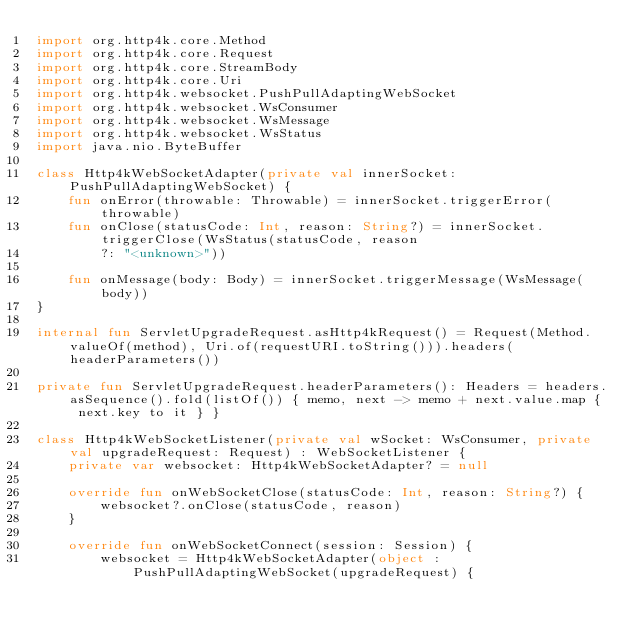Convert code to text. <code><loc_0><loc_0><loc_500><loc_500><_Kotlin_>import org.http4k.core.Method
import org.http4k.core.Request
import org.http4k.core.StreamBody
import org.http4k.core.Uri
import org.http4k.websocket.PushPullAdaptingWebSocket
import org.http4k.websocket.WsConsumer
import org.http4k.websocket.WsMessage
import org.http4k.websocket.WsStatus
import java.nio.ByteBuffer

class Http4kWebSocketAdapter(private val innerSocket: PushPullAdaptingWebSocket) {
    fun onError(throwable: Throwable) = innerSocket.triggerError(throwable)
    fun onClose(statusCode: Int, reason: String?) = innerSocket.triggerClose(WsStatus(statusCode, reason
        ?: "<unknown>"))

    fun onMessage(body: Body) = innerSocket.triggerMessage(WsMessage(body))
}

internal fun ServletUpgradeRequest.asHttp4kRequest() = Request(Method.valueOf(method), Uri.of(requestURI.toString())).headers(headerParameters())

private fun ServletUpgradeRequest.headerParameters(): Headers = headers.asSequence().fold(listOf()) { memo, next -> memo + next.value.map { next.key to it } }

class Http4kWebSocketListener(private val wSocket: WsConsumer, private val upgradeRequest: Request) : WebSocketListener {
    private var websocket: Http4kWebSocketAdapter? = null

    override fun onWebSocketClose(statusCode: Int, reason: String?) {
        websocket?.onClose(statusCode, reason)
    }

    override fun onWebSocketConnect(session: Session) {
        websocket = Http4kWebSocketAdapter(object : PushPullAdaptingWebSocket(upgradeRequest) {</code> 